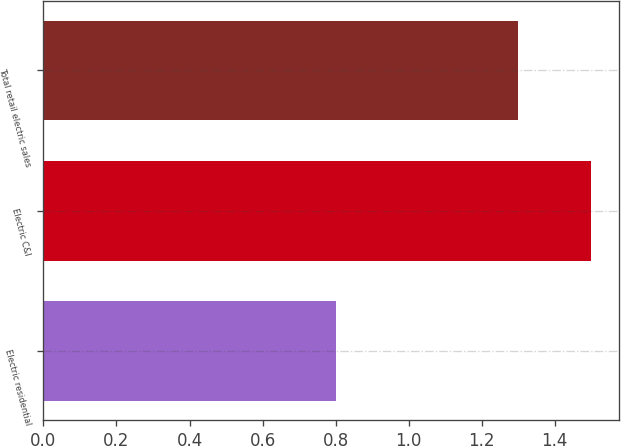Convert chart. <chart><loc_0><loc_0><loc_500><loc_500><bar_chart><fcel>Electric residential<fcel>Electric C&I<fcel>Total retail electric sales<nl><fcel>0.8<fcel>1.5<fcel>1.3<nl></chart> 